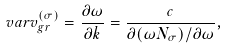Convert formula to latex. <formula><loc_0><loc_0><loc_500><loc_500>\ v a r v _ { g r } ^ { ( \sigma ) } = \frac { \partial \omega } { \partial k } = \frac { c } { \partial ( \omega N _ { \sigma } ) / \partial \omega } ,</formula> 